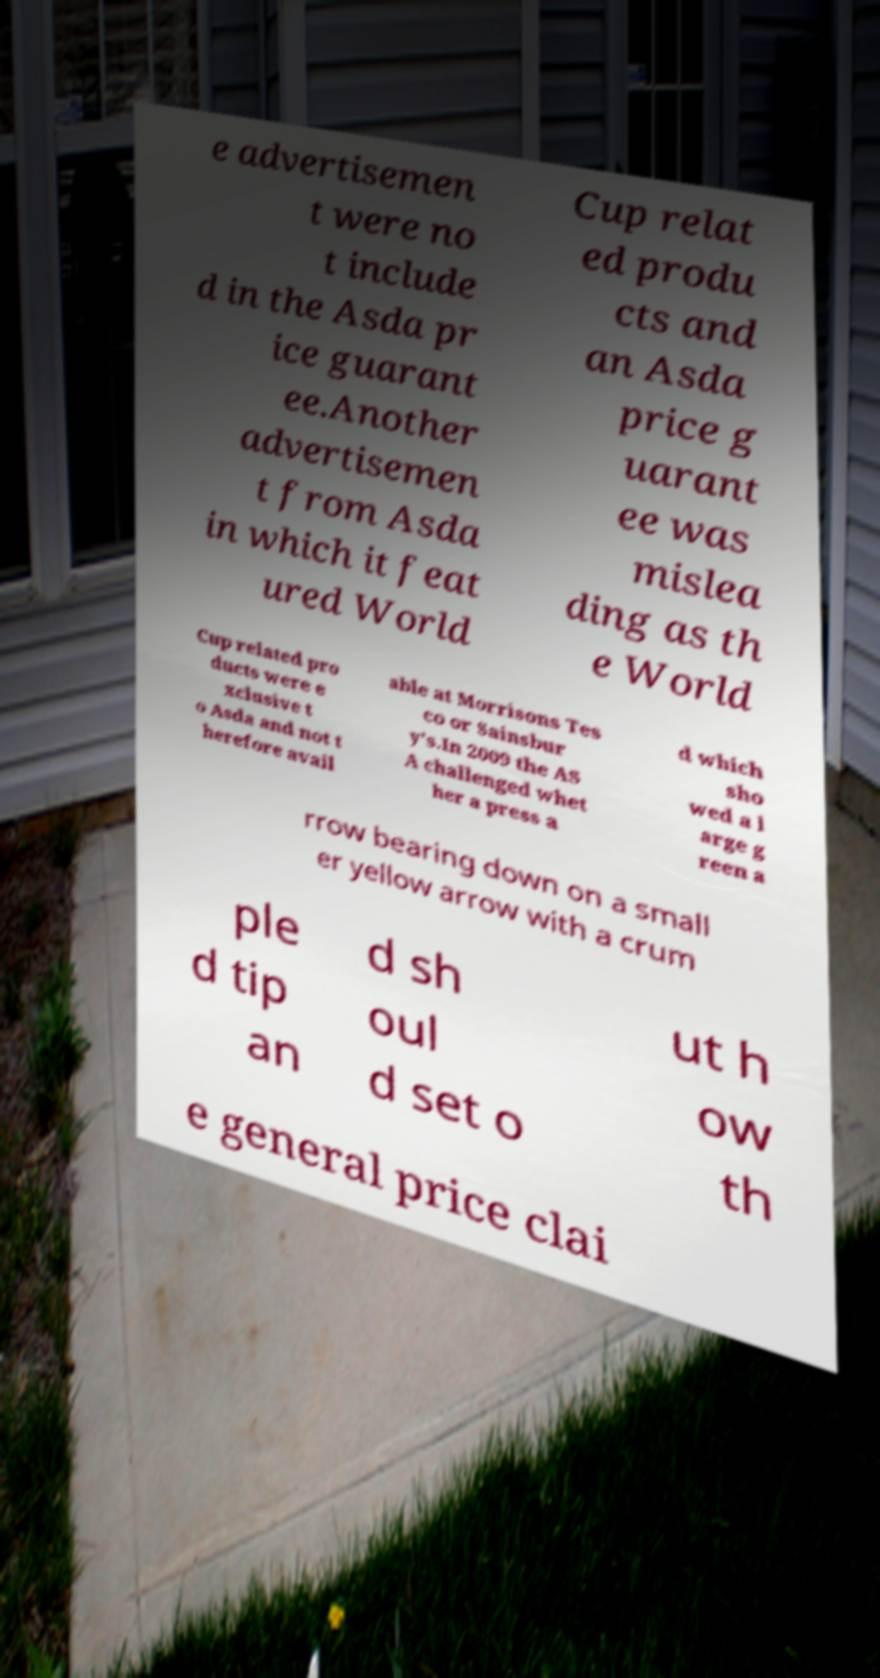Can you read and provide the text displayed in the image?This photo seems to have some interesting text. Can you extract and type it out for me? e advertisemen t were no t include d in the Asda pr ice guarant ee.Another advertisemen t from Asda in which it feat ured World Cup relat ed produ cts and an Asda price g uarant ee was mislea ding as th e World Cup related pro ducts were e xclusive t o Asda and not t herefore avail able at Morrisons Tes co or Sainsbur y's.In 2009 the AS A challenged whet her a press a d which sho wed a l arge g reen a rrow bearing down on a small er yellow arrow with a crum ple d tip an d sh oul d set o ut h ow th e general price clai 